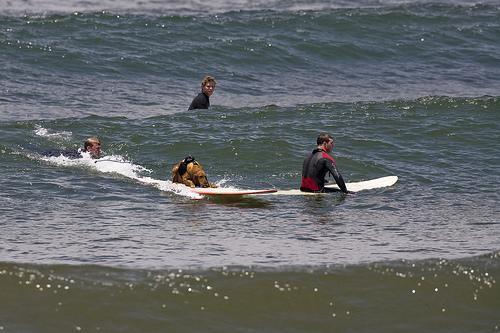How many people are visible in the water?
Give a very brief answer. 3. How many animals are pictured?
Give a very brief answer. 1. How many kids are visible?
Give a very brief answer. 0. 